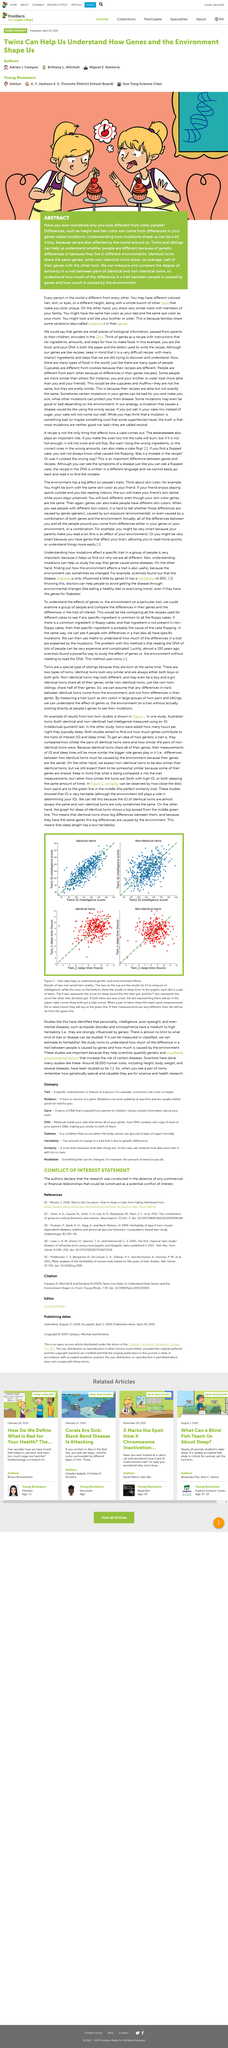List a handful of essential elements in this visual. Yes, identical twins share the same genes. According to the study, the sleep length has low heritability, meaning that the genetic factors play a limited role in determining the sleep length. Genes, known as mutations, are responsible for the differences in appearance between individuals. Both studies aimed to determine the number of genes that contribute to the traits of interest. Similarity is observed in figure 1 by how close the dots are to the green line in the middle. 